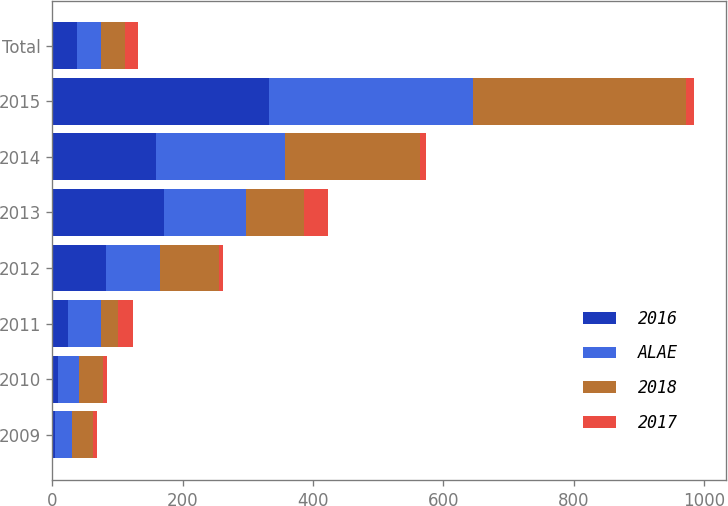Convert chart to OTSL. <chart><loc_0><loc_0><loc_500><loc_500><stacked_bar_chart><ecel><fcel>2009<fcel>2010<fcel>2011<fcel>2012<fcel>2013<fcel>2014<fcel>2015<fcel>Total<nl><fcel>2016<fcel>4<fcel>9<fcel>24<fcel>82<fcel>171<fcel>159<fcel>333<fcel>37<nl><fcel>ALAE<fcel>26<fcel>31<fcel>50<fcel>83<fcel>126<fcel>198<fcel>313<fcel>37<nl><fcel>2018<fcel>32<fcel>37<fcel>26<fcel>90<fcel>89<fcel>207<fcel>326<fcel>37<nl><fcel>2017<fcel>6<fcel>6<fcel>24<fcel>7<fcel>37<fcel>9<fcel>13<fcel>20<nl></chart> 